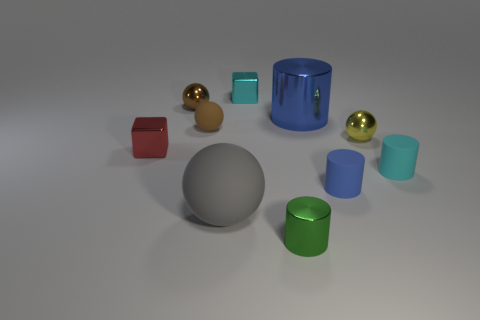Subtract all blocks. How many objects are left? 8 Add 5 tiny yellow spheres. How many tiny yellow spheres exist? 6 Subtract 2 blue cylinders. How many objects are left? 8 Subtract all large blue cylinders. Subtract all cyan matte things. How many objects are left? 8 Add 4 tiny blue rubber cylinders. How many tiny blue rubber cylinders are left? 5 